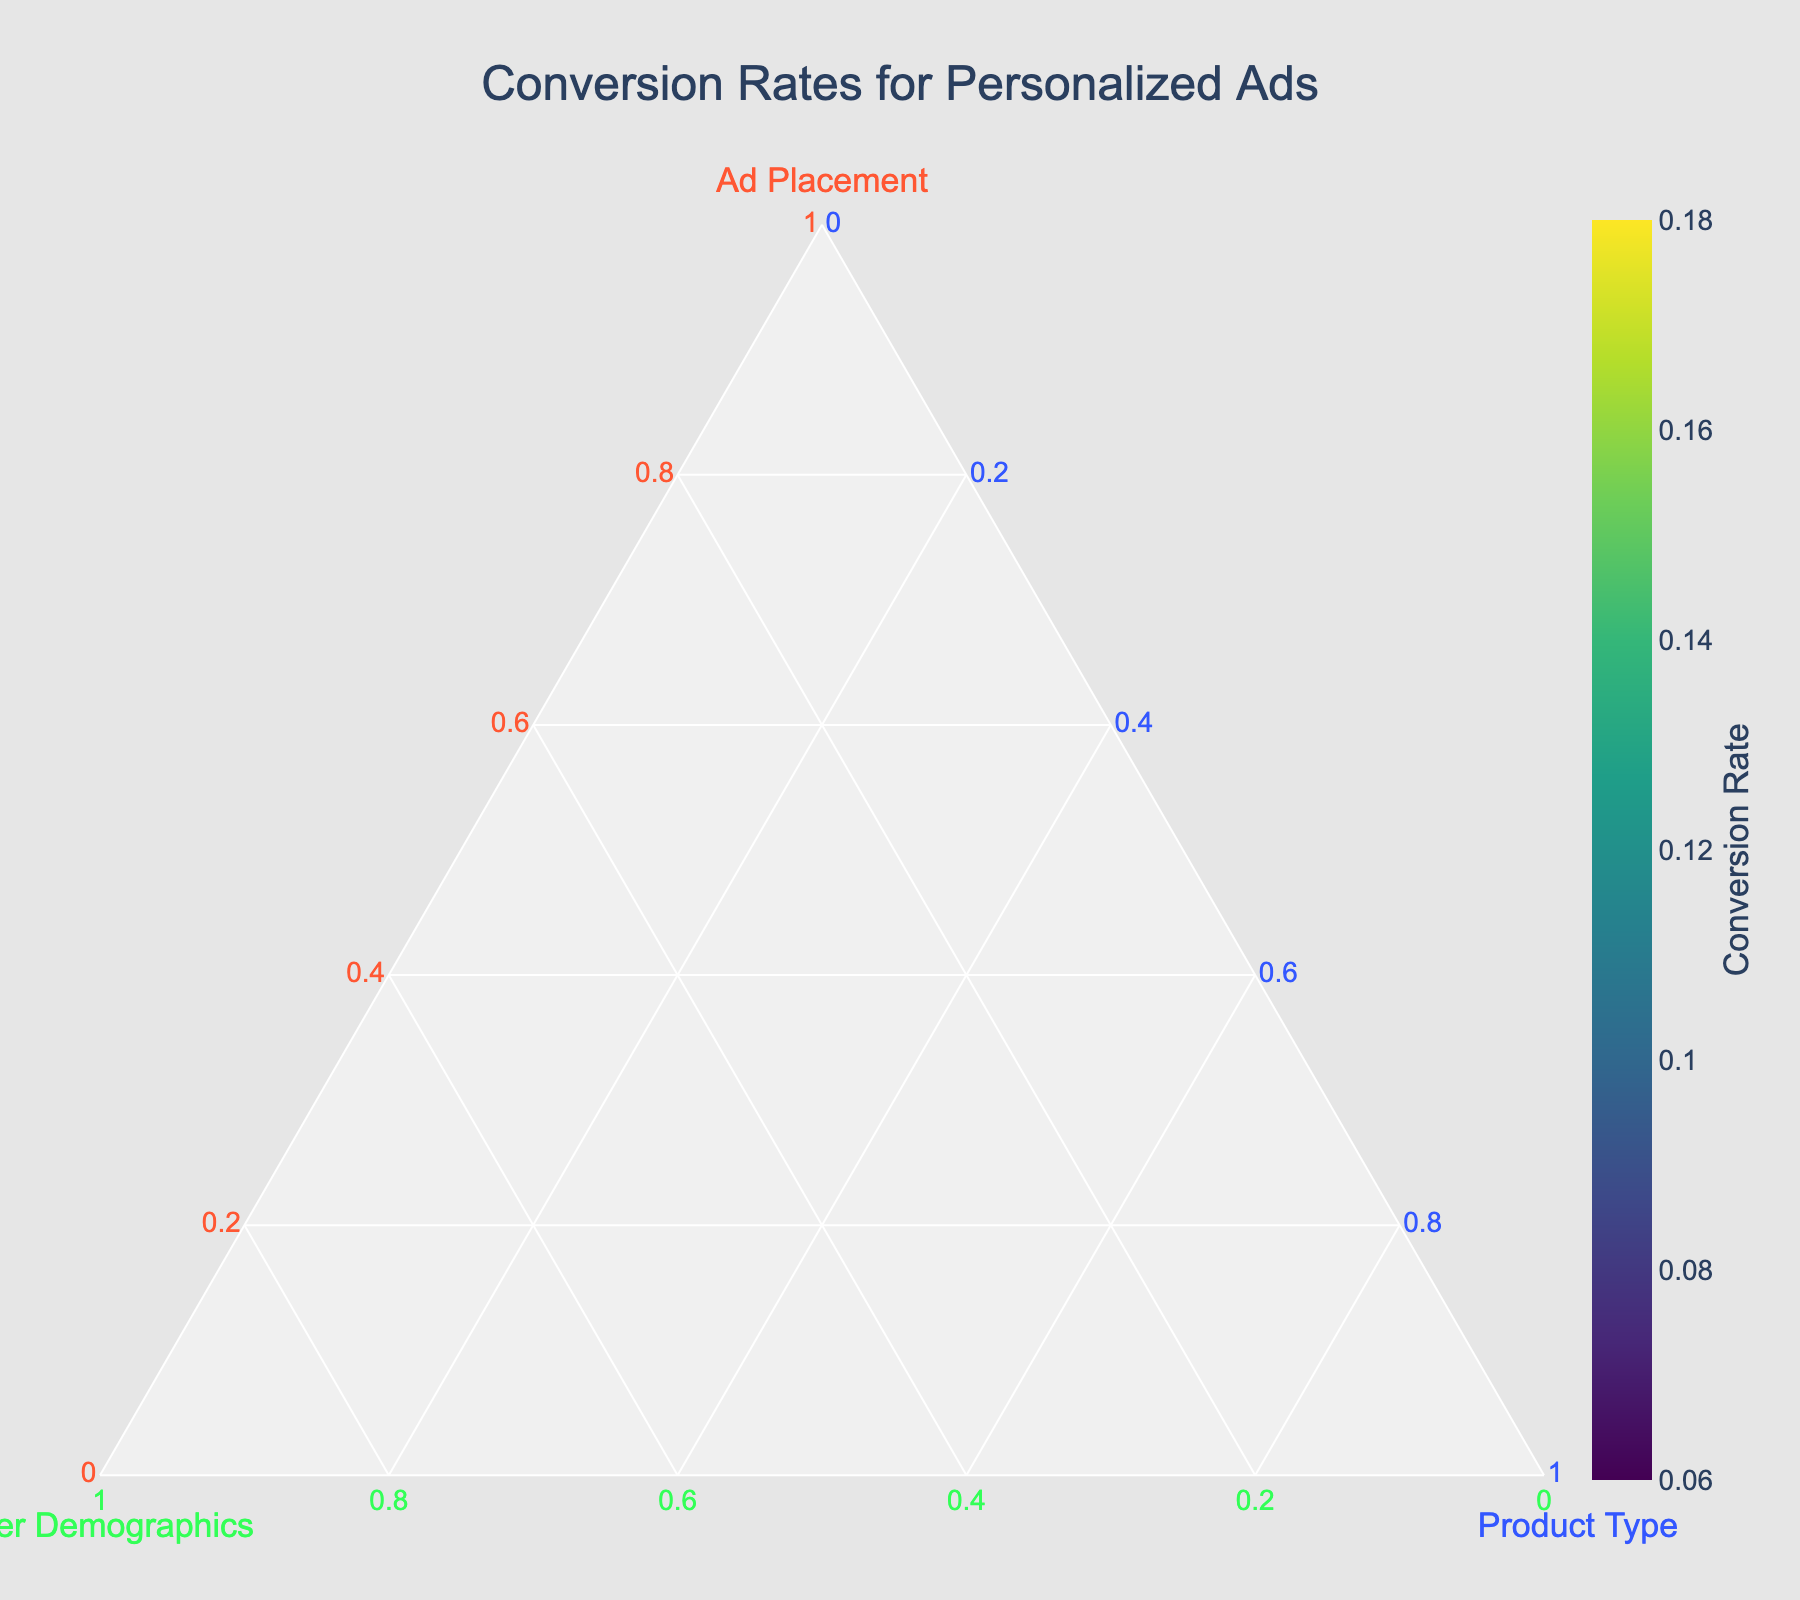What is the title of the figure? The title of the figure is located at the top center and reads "Conversion Rates for Personalized Ads".
Answer: Conversion Rates for Personalized Ads How many data points are represented in the ternary plot? Each point on the ternary plot corresponds to one of the data rows. By counting the number of unique diamond markers, we can see there are 14 data points.
Answer: 14 Which product type has the highest conversion rate for Email ads? By examining the color legend and noting the color corresponding to Email ads, we see that Beauty Products have the highest conversion rate.
Answer: Beauty Products What is the average conversion rate for Young Adults across all ad placements? For Young Adults, the conversion rates are 0.15 (Electronics, Homepage), 0.11 (Sports Equipment, Search Results), 0.13 (Kitchen Appliances, Banner), 0.09 (Furniture, Sponsored Content). Summing these rates gives 0.48. There are 4 data points, so the average is 0.48/4.
Answer: 0.12 Which ad placement yields the lowest conversion rate overall? By comparing the colors, which indicate conversion rates, of various ad placements (taking note that darker colors imply lower conversion rates), Retargeting has the lowest conversion rate of 0.06.
Answer: Retargeting Is the conversion rate from Social Media higher for Teenagers or Seniors? By locating Social Media in the ternary plot and observing the conversion rates, we see that Teenagers have a conversion rate of 0.17 (Electronics) while Seniors have a conversion rate of 0.08 (Home Decor). 0.17 is greater than 0.08.
Answer: Teenagers Do Middle-aged customers have a higher or lower average conversion rate compared to Teenagers? Middle-aged: (0.12+0.09+0.10+0.11) = 0.42, average = 0.42/4 = 0.105. Teenagers: (0.18+0.14+0.17+0.16) = 0.65, average = 0.65/4 = 0.1625. Comparing the two averages, Teenagers have a higher conversion rate.
Answer: Higher What is the most common customer demographic in the dataset? By examining the labels in the ternary plot, we can count the occurrence of each customer demographic. Young Adults appear the most frequently with 5 occurrences.
Answer: Young Adults Which product type has the most diverse ad placement categories represented? By examining the plot and identifying the product type with the most unique ad placements connected to it, Electronics has multiple ad placements like Homepage and Social Media.
Answer: Electronics Using the plot, what can you infer about the relationship between ad placement and conversion rate for Teenagers on Social Media? Teenagers on Social Media have a conversion rate of 0.17 for Electronics, which is relatively high. This suggests that Social Media is an effective ad placement for Teenage customers.
Answer: High conversion rate 